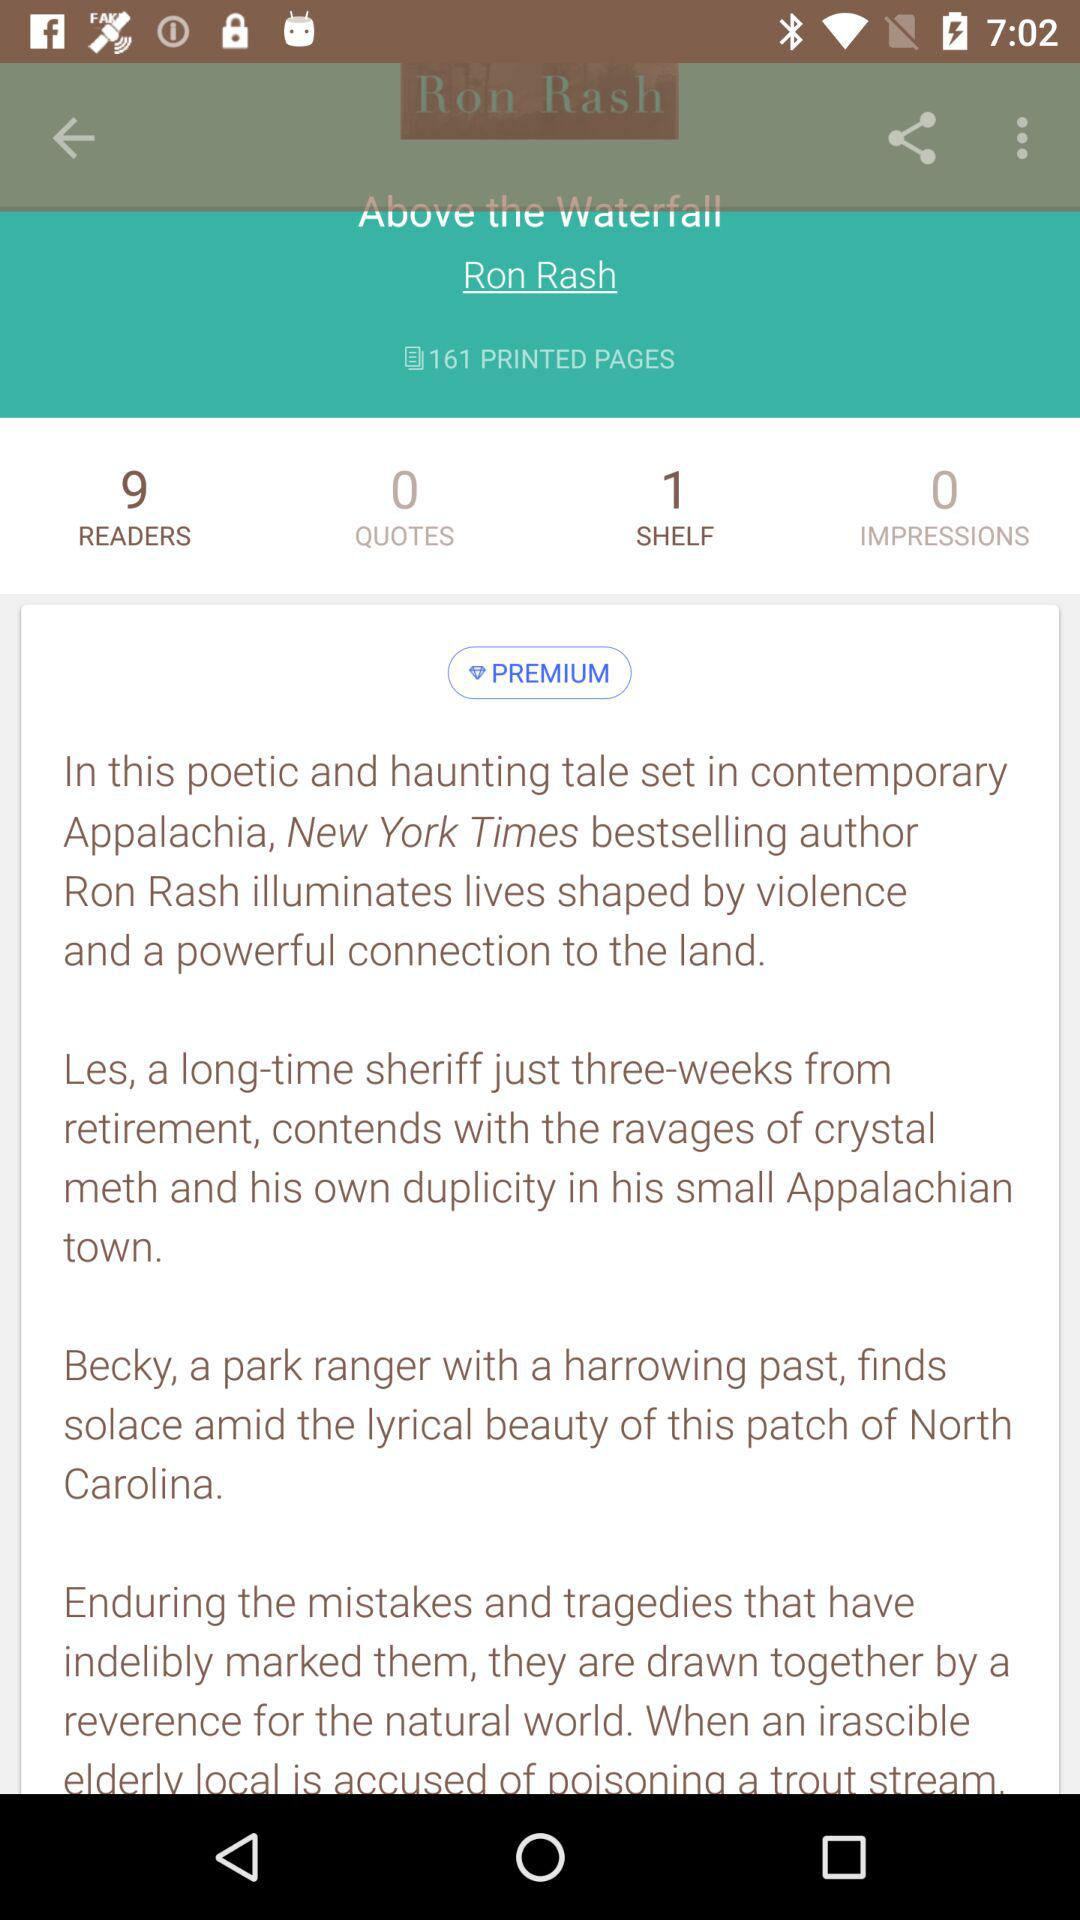What is the total number of quotes there? There are 0 qoutes in total. 